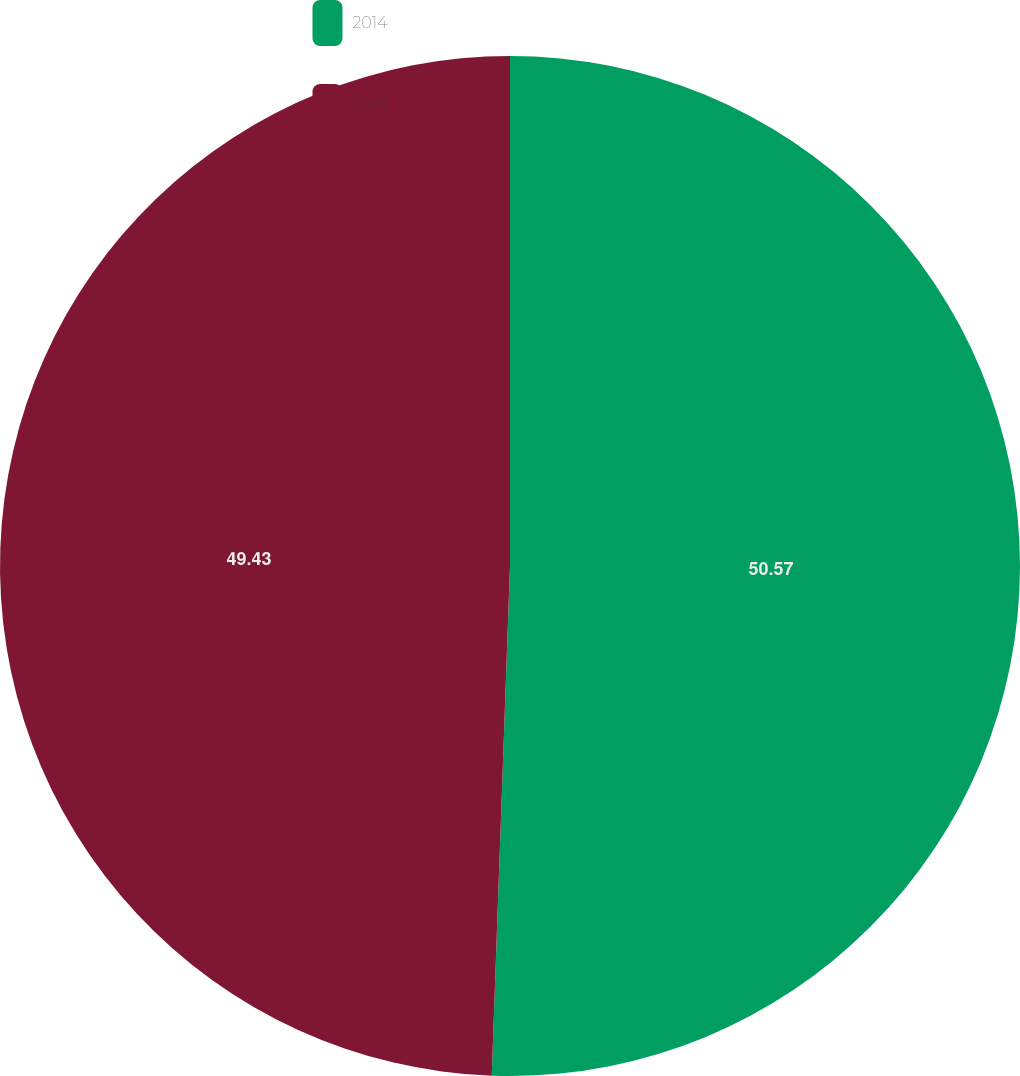<chart> <loc_0><loc_0><loc_500><loc_500><pie_chart><fcel>2014<fcel>2013<nl><fcel>50.57%<fcel>49.43%<nl></chart> 